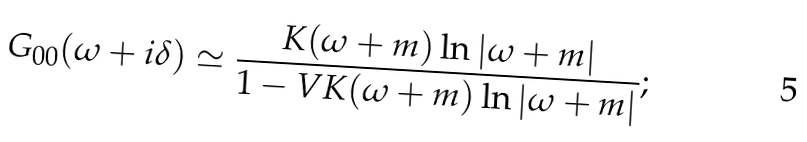<formula> <loc_0><loc_0><loc_500><loc_500>G _ { 0 0 } ( \omega + i \delta ) \simeq \frac { K ( \omega + m ) \ln \left | \omega + m \right | } { 1 - V K ( \omega + m ) \ln \left | \omega + m \right | } ;</formula> 